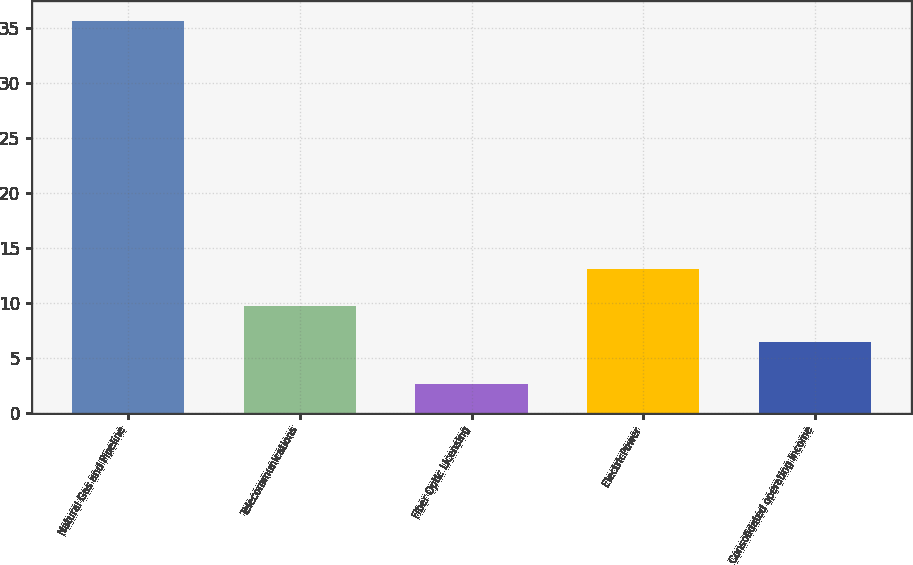Convert chart. <chart><loc_0><loc_0><loc_500><loc_500><bar_chart><fcel>Natural Gas and Pipeline<fcel>Telecommunications<fcel>Fiber Optic Licensing<fcel>ElectricPower<fcel>Consolidated operating income<nl><fcel>35.7<fcel>9.8<fcel>2.7<fcel>13.1<fcel>6.5<nl></chart> 